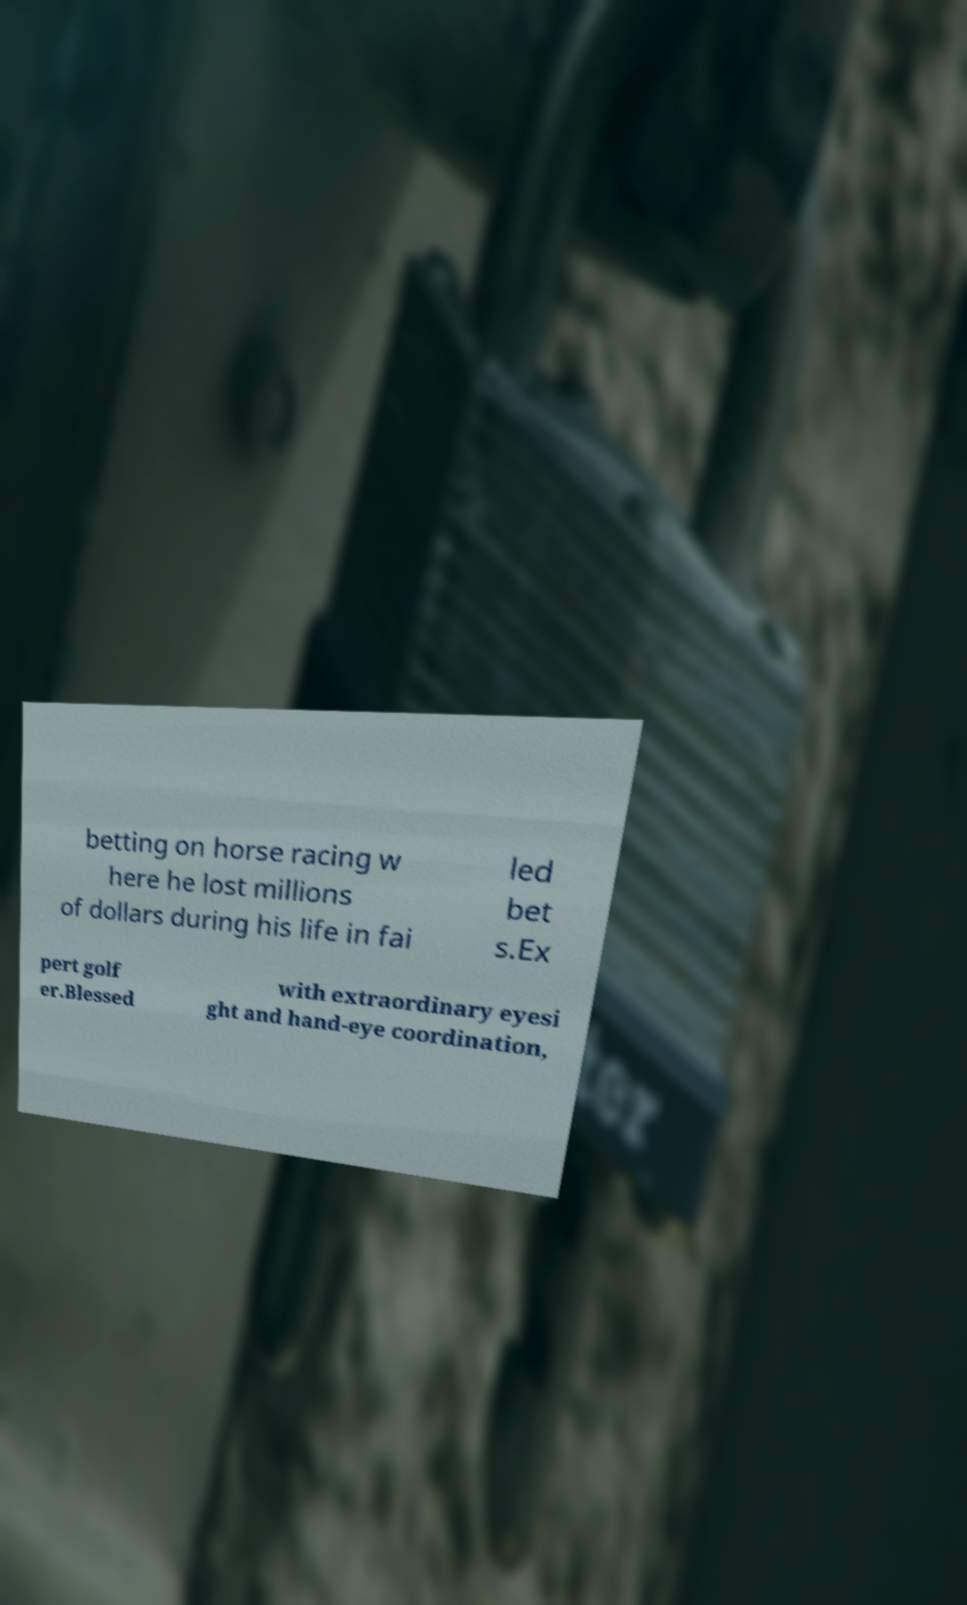For documentation purposes, I need the text within this image transcribed. Could you provide that? betting on horse racing w here he lost millions of dollars during his life in fai led bet s.Ex pert golf er.Blessed with extraordinary eyesi ght and hand-eye coordination, 